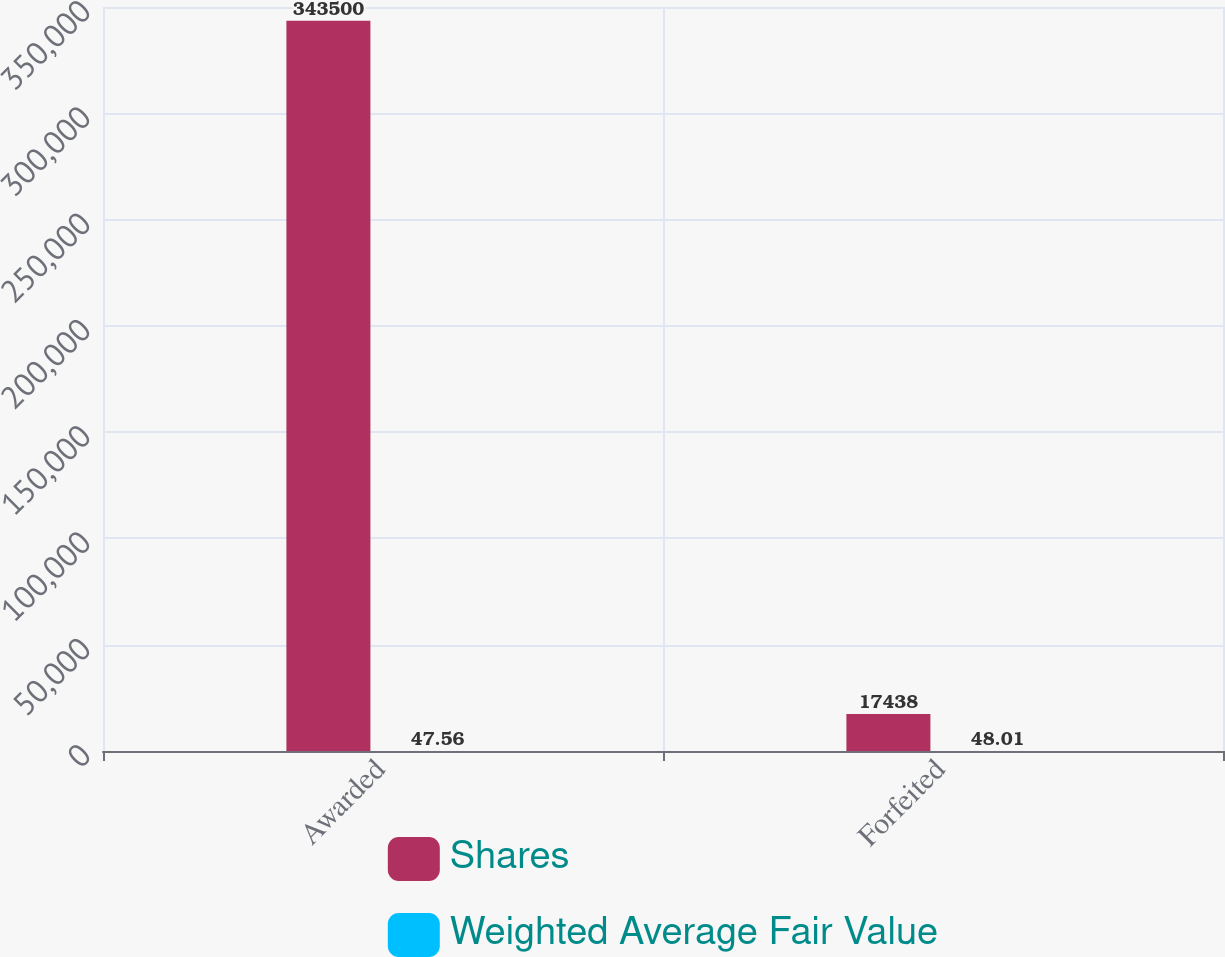Convert chart. <chart><loc_0><loc_0><loc_500><loc_500><stacked_bar_chart><ecel><fcel>Awarded<fcel>Forfeited<nl><fcel>Shares<fcel>343500<fcel>17438<nl><fcel>Weighted Average Fair Value<fcel>47.56<fcel>48.01<nl></chart> 